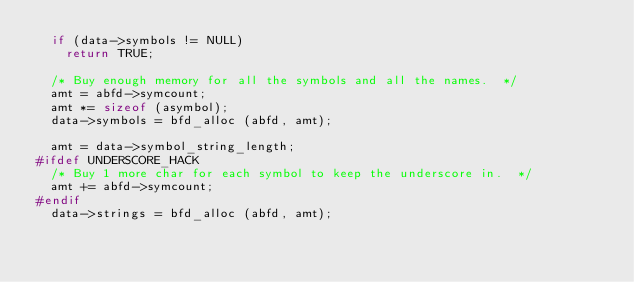Convert code to text. <code><loc_0><loc_0><loc_500><loc_500><_C_>  if (data->symbols != NULL)
    return TRUE;

  /* Buy enough memory for all the symbols and all the names.  */
  amt = abfd->symcount;
  amt *= sizeof (asymbol);
  data->symbols = bfd_alloc (abfd, amt);

  amt = data->symbol_string_length;
#ifdef UNDERSCORE_HACK
  /* Buy 1 more char for each symbol to keep the underscore in.  */
  amt += abfd->symcount;
#endif
  data->strings = bfd_alloc (abfd, amt);
</code> 